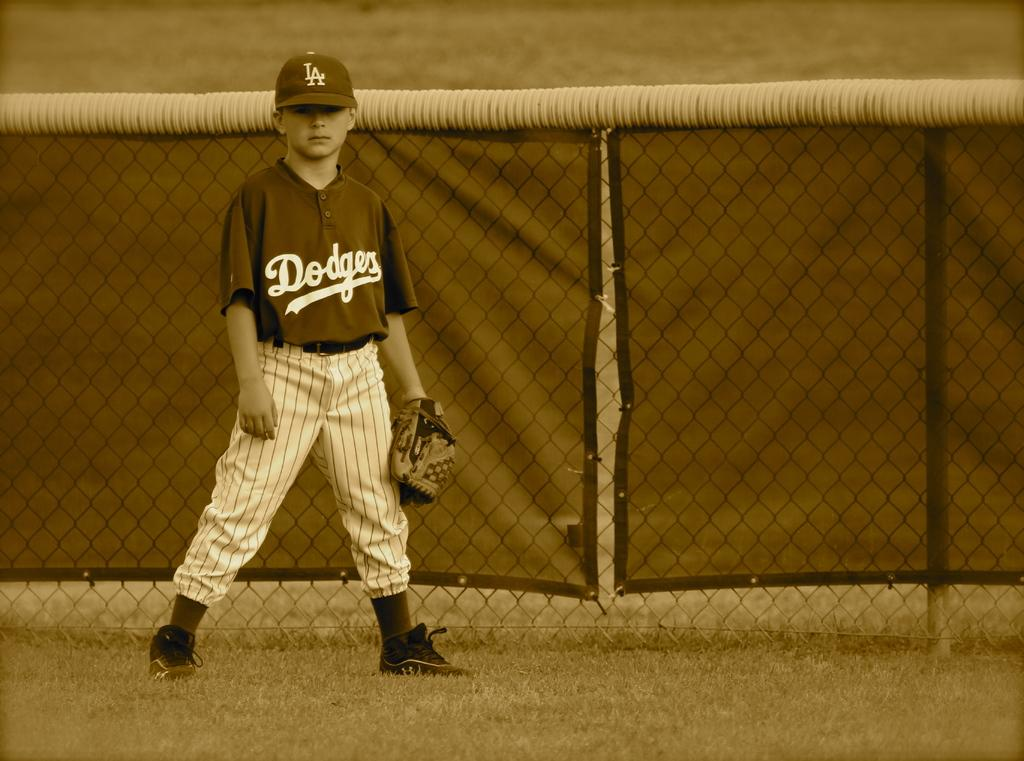<image>
Summarize the visual content of the image. Baseball player wearing a jersey that says Dodgers on it. 